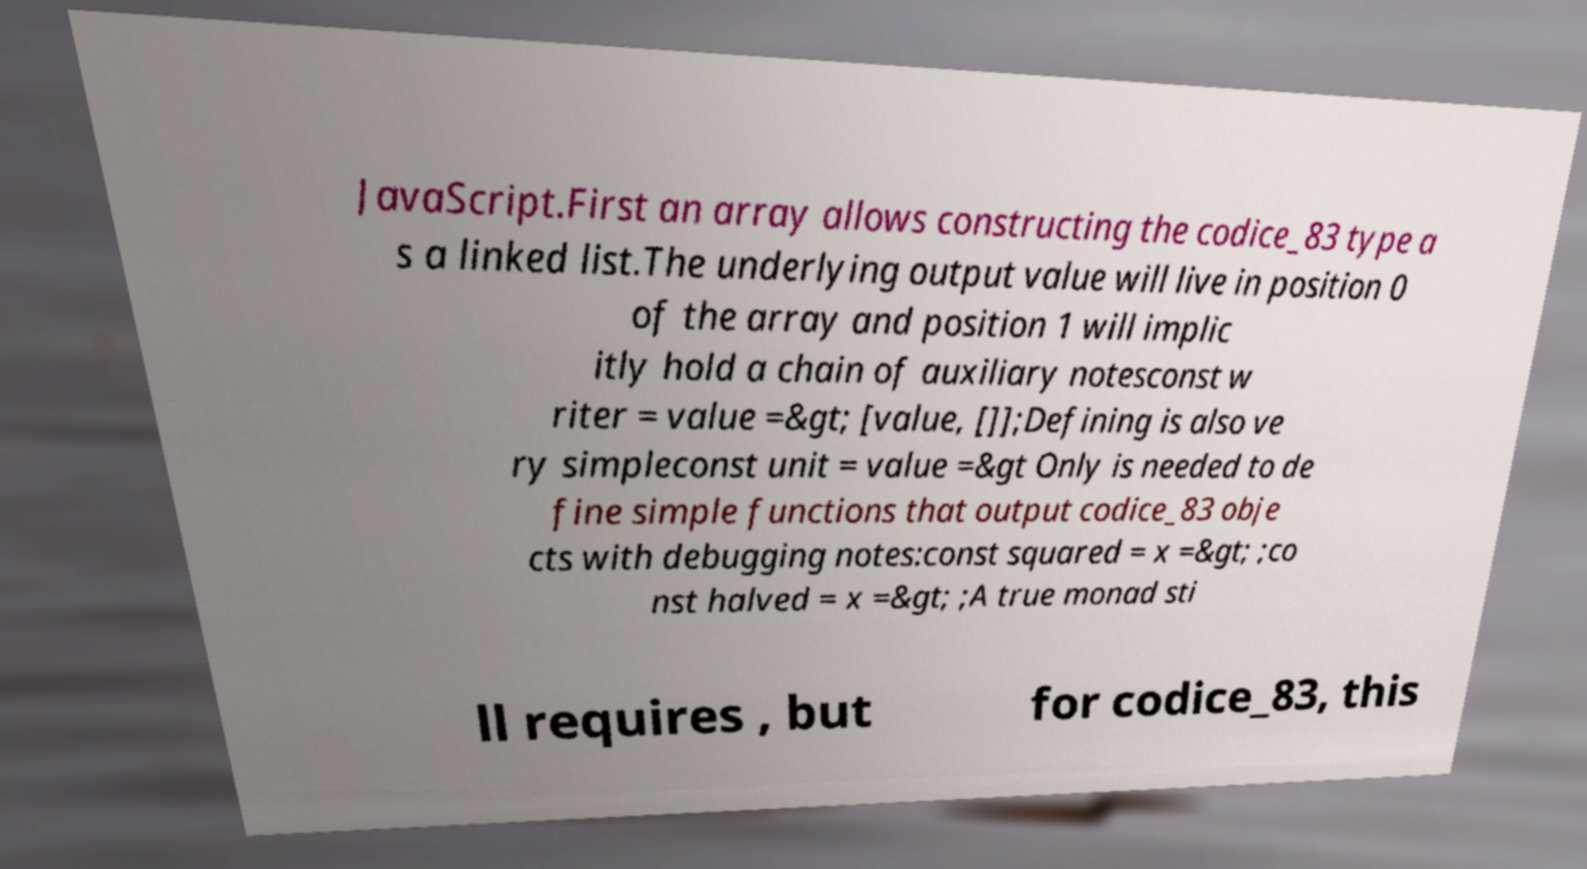Could you assist in decoding the text presented in this image and type it out clearly? JavaScript.First an array allows constructing the codice_83 type a s a linked list.The underlying output value will live in position 0 of the array and position 1 will implic itly hold a chain of auxiliary notesconst w riter = value =&gt; [value, []];Defining is also ve ry simpleconst unit = value =&gt Only is needed to de fine simple functions that output codice_83 obje cts with debugging notes:const squared = x =&gt; ;co nst halved = x =&gt; ;A true monad sti ll requires , but for codice_83, this 